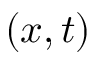Convert formula to latex. <formula><loc_0><loc_0><loc_500><loc_500>( x , t )</formula> 